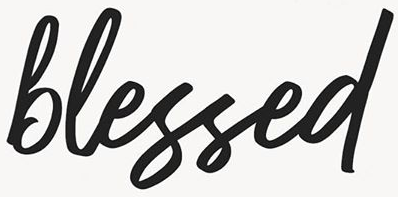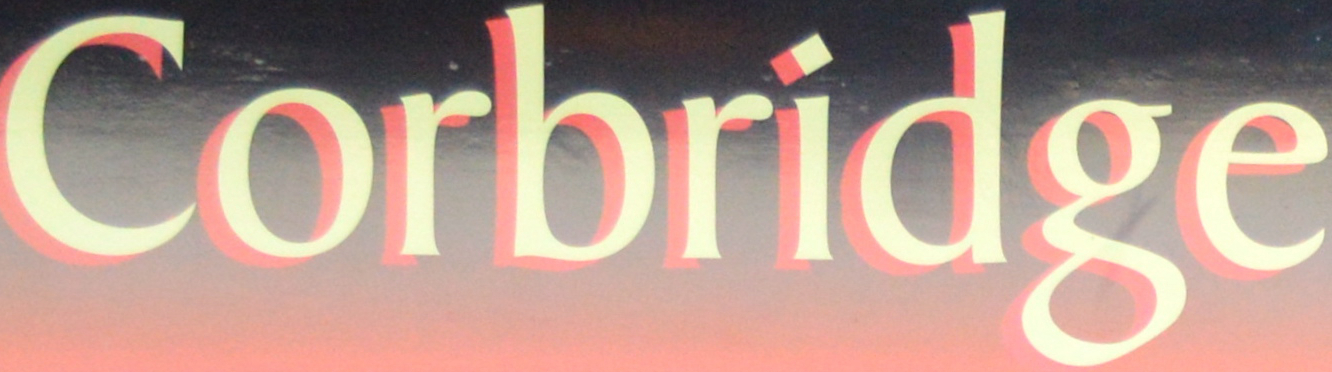What words can you see in these images in sequence, separated by a semicolon? blessed; Corbridge 